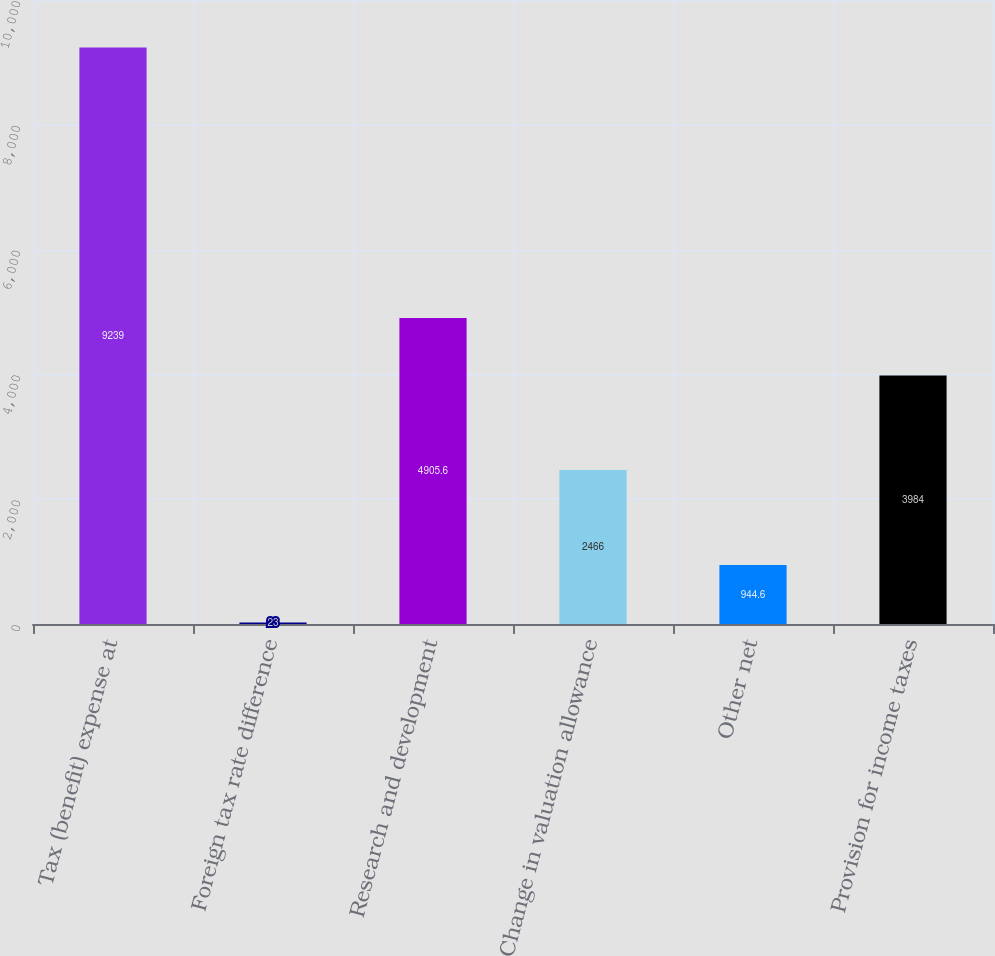<chart> <loc_0><loc_0><loc_500><loc_500><bar_chart><fcel>Tax (benefit) expense at<fcel>Foreign tax rate difference<fcel>Research and development<fcel>Change in valuation allowance<fcel>Other net<fcel>Provision for income taxes<nl><fcel>9239<fcel>23<fcel>4905.6<fcel>2466<fcel>944.6<fcel>3984<nl></chart> 